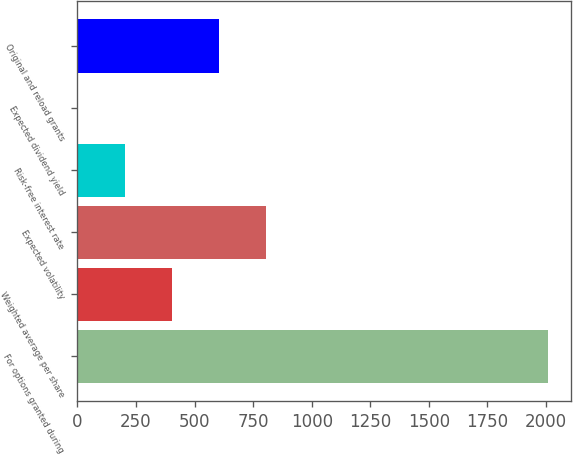<chart> <loc_0><loc_0><loc_500><loc_500><bar_chart><fcel>For options granted during<fcel>Weighted average per share<fcel>Expected volatility<fcel>Risk-free interest rate<fcel>Expected dividend yield<fcel>Original and reload grants<nl><fcel>2007<fcel>404.63<fcel>805.23<fcel>204.33<fcel>4.03<fcel>604.93<nl></chart> 